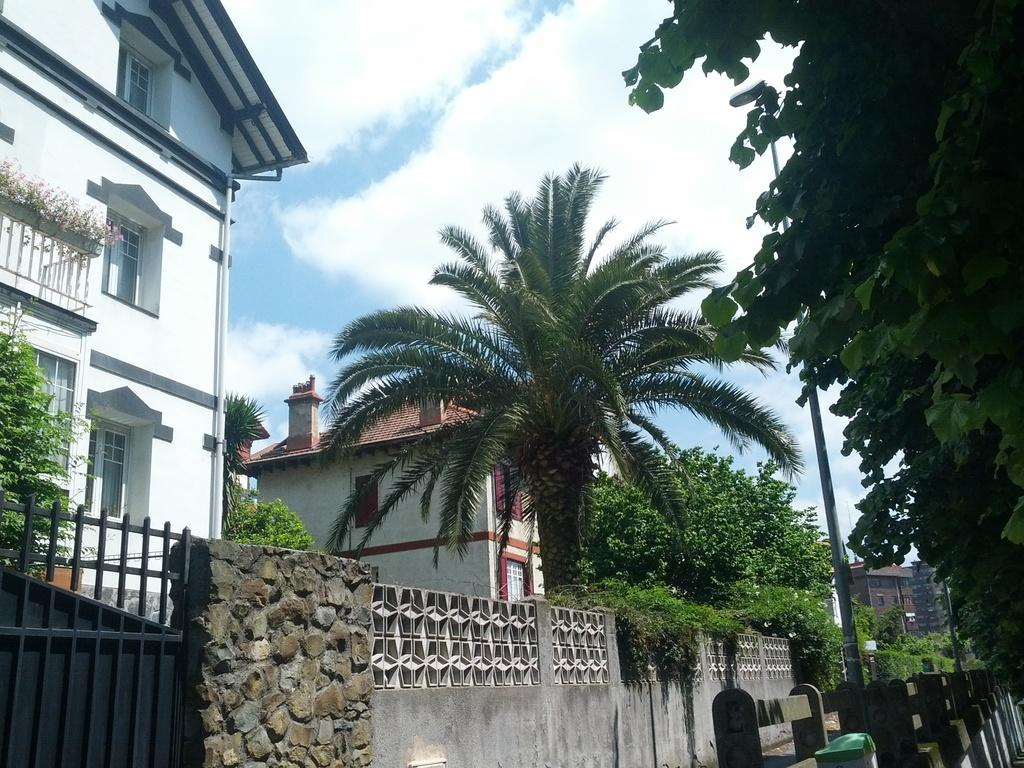What type of barrier can be seen in the image? There is a fence in the image. What other structure is present in the image? There is a wall in the image. What type of entrance is visible in the image? There is a metal gate in the image. What type of vegetation is present in the image? There are many trees in the image. What type of vertical structures can be seen in the image? There are poles in the image. What can be seen in the background of the image? There are many buildings and clouds in the background of the image, and the sky is visible. What color is the vacation in the image? There is no vacation present in the image; it is a scene with a fence, wall, metal gate, trees, poles, buildings, clouds, and sky. What type of alarm is attached to the trees in the image? There are no alarms present in the image; it features a fence, wall, metal gate, trees, poles, buildings, clouds, and sky. 